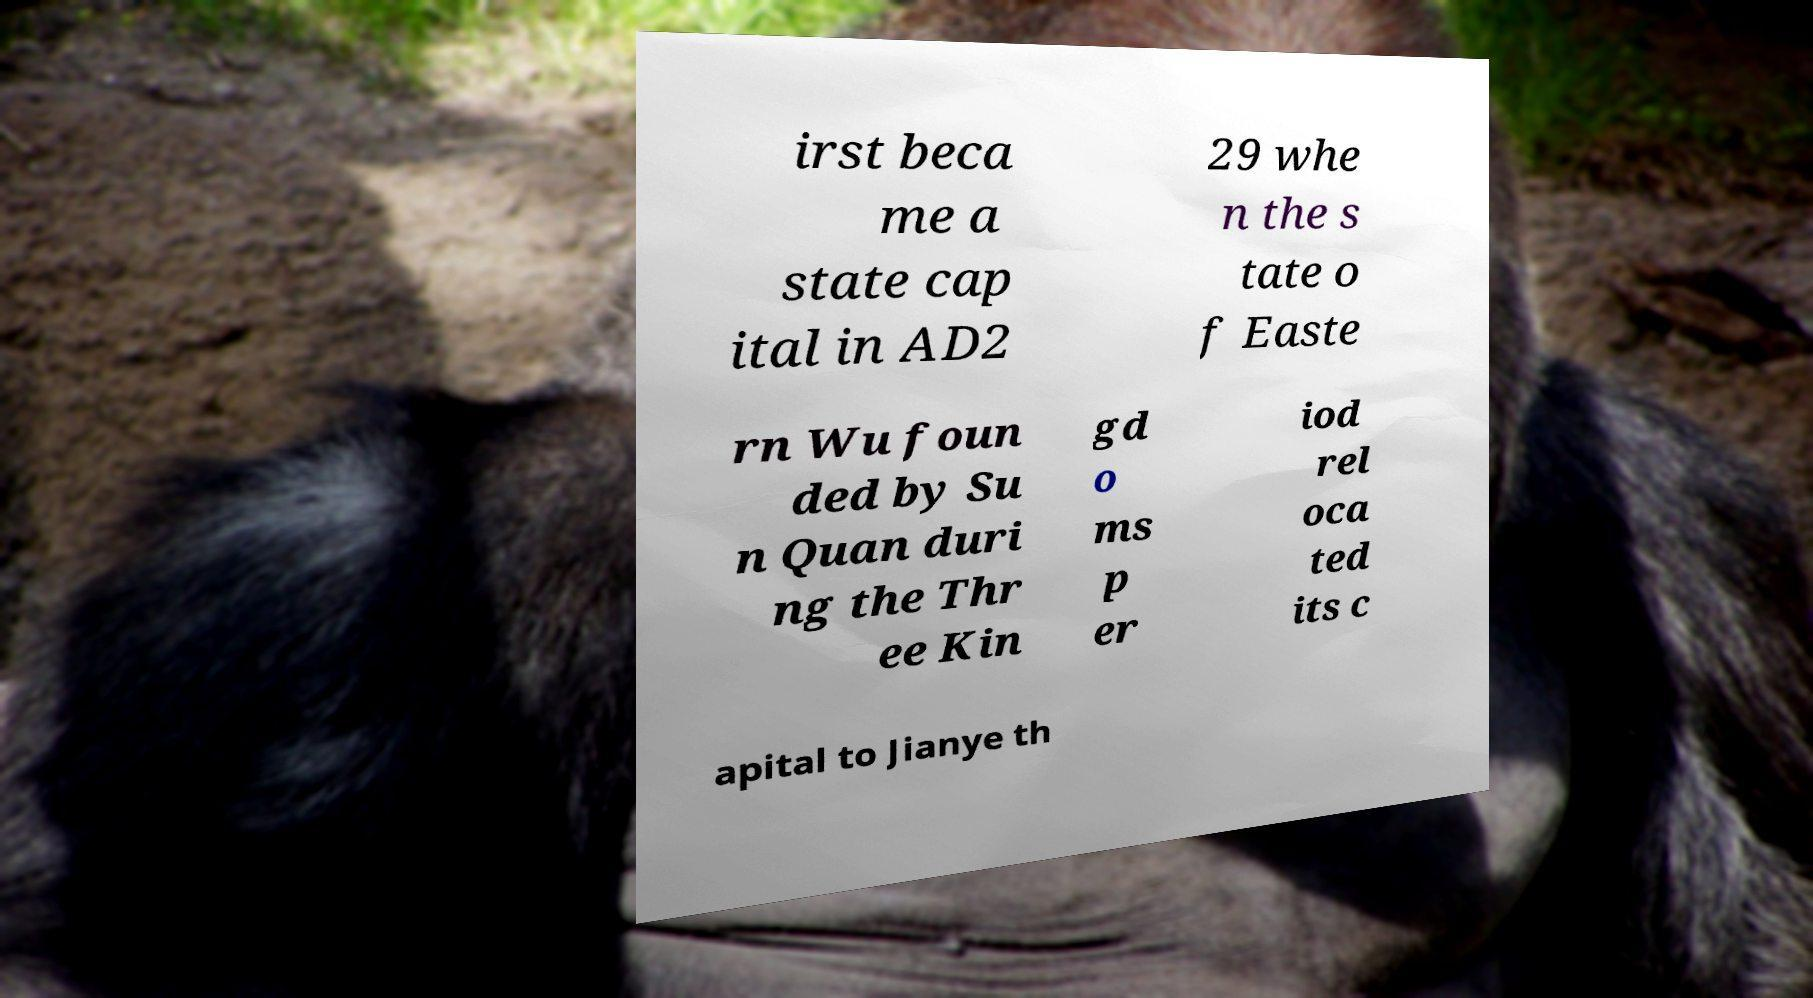Could you assist in decoding the text presented in this image and type it out clearly? irst beca me a state cap ital in AD2 29 whe n the s tate o f Easte rn Wu foun ded by Su n Quan duri ng the Thr ee Kin gd o ms p er iod rel oca ted its c apital to Jianye th 